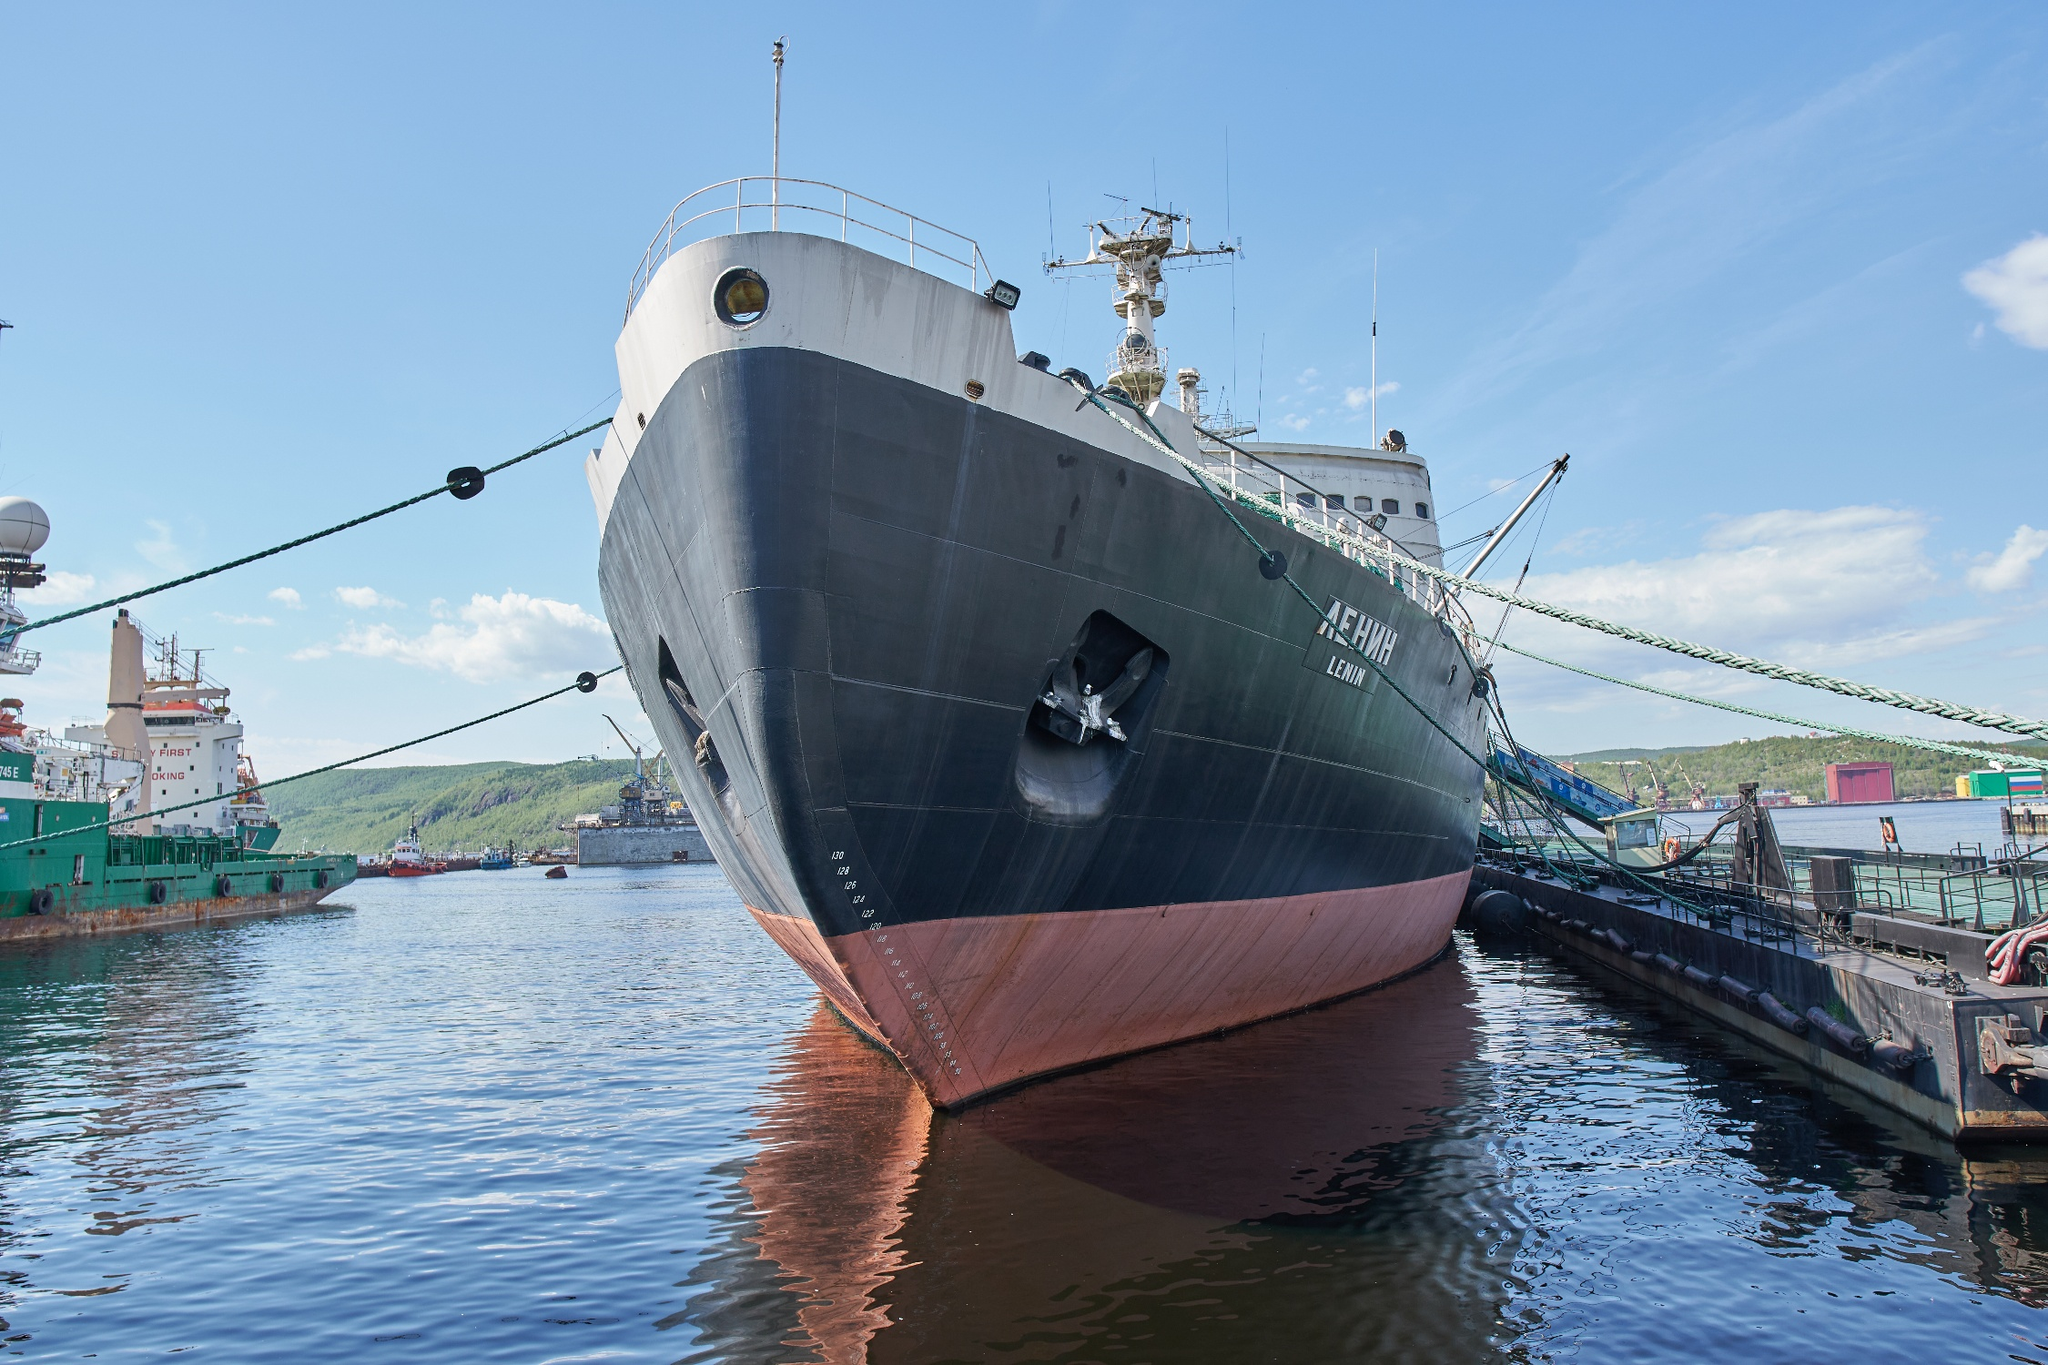Imagine this ship in a completely different universe. What kind of adventures would it have? In an alternate universe, the Lenin wouldn't just traverse the icy waters of Earth but would journey through the cosmic ice fields of distant planets. As an interstellar exploration vessel, it would break through crystalline icebergs floating in space, perhaps delving into the ice-covered seas of a moon like Europa. On these adventures, the ship would encounter alien marine life, decipher mysterious signals from beneath the ice, and uncover ancient, frozen relics of a bygone extraterrestrial civilization. Each voyage would be a blend of scientific discovery and intergalactic folklore, with the Lenin becoming a legendary name known across star systems. 